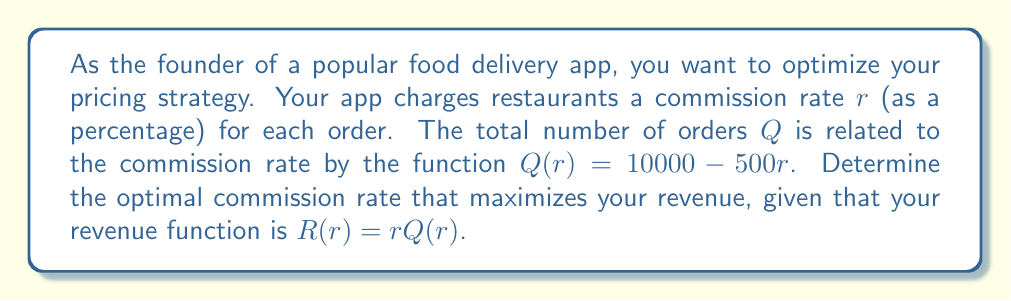Give your solution to this math problem. 1. First, let's express the revenue function in terms of $r$:
   $R(r) = r(10000 - 500r) = 10000r - 500r^2$

2. To find the maximum revenue, we need to find the derivative of $R(r)$ and set it equal to zero:
   $$\frac{dR}{dr} = 10000 - 1000r$$

3. Set the derivative equal to zero and solve for $r$:
   $$10000 - 1000r = 0$$
   $$1000r = 10000$$
   $$r = 10$$

4. To confirm this is a maximum, we can check the second derivative:
   $$\frac{d^2R}{dr^2} = -1000$$
   Since this is negative, we confirm that $r = 10$ gives a maximum.

5. The optimal commission rate is 10%, or 0.10 in decimal form.

6. We can calculate the maximum revenue:
   $R(10) = 10(10000 - 500(10)) = 10(5000) = 50000$

Therefore, the optimal commission rate is 10%, which will result in a maximum revenue of $50,000.
Answer: 10% 